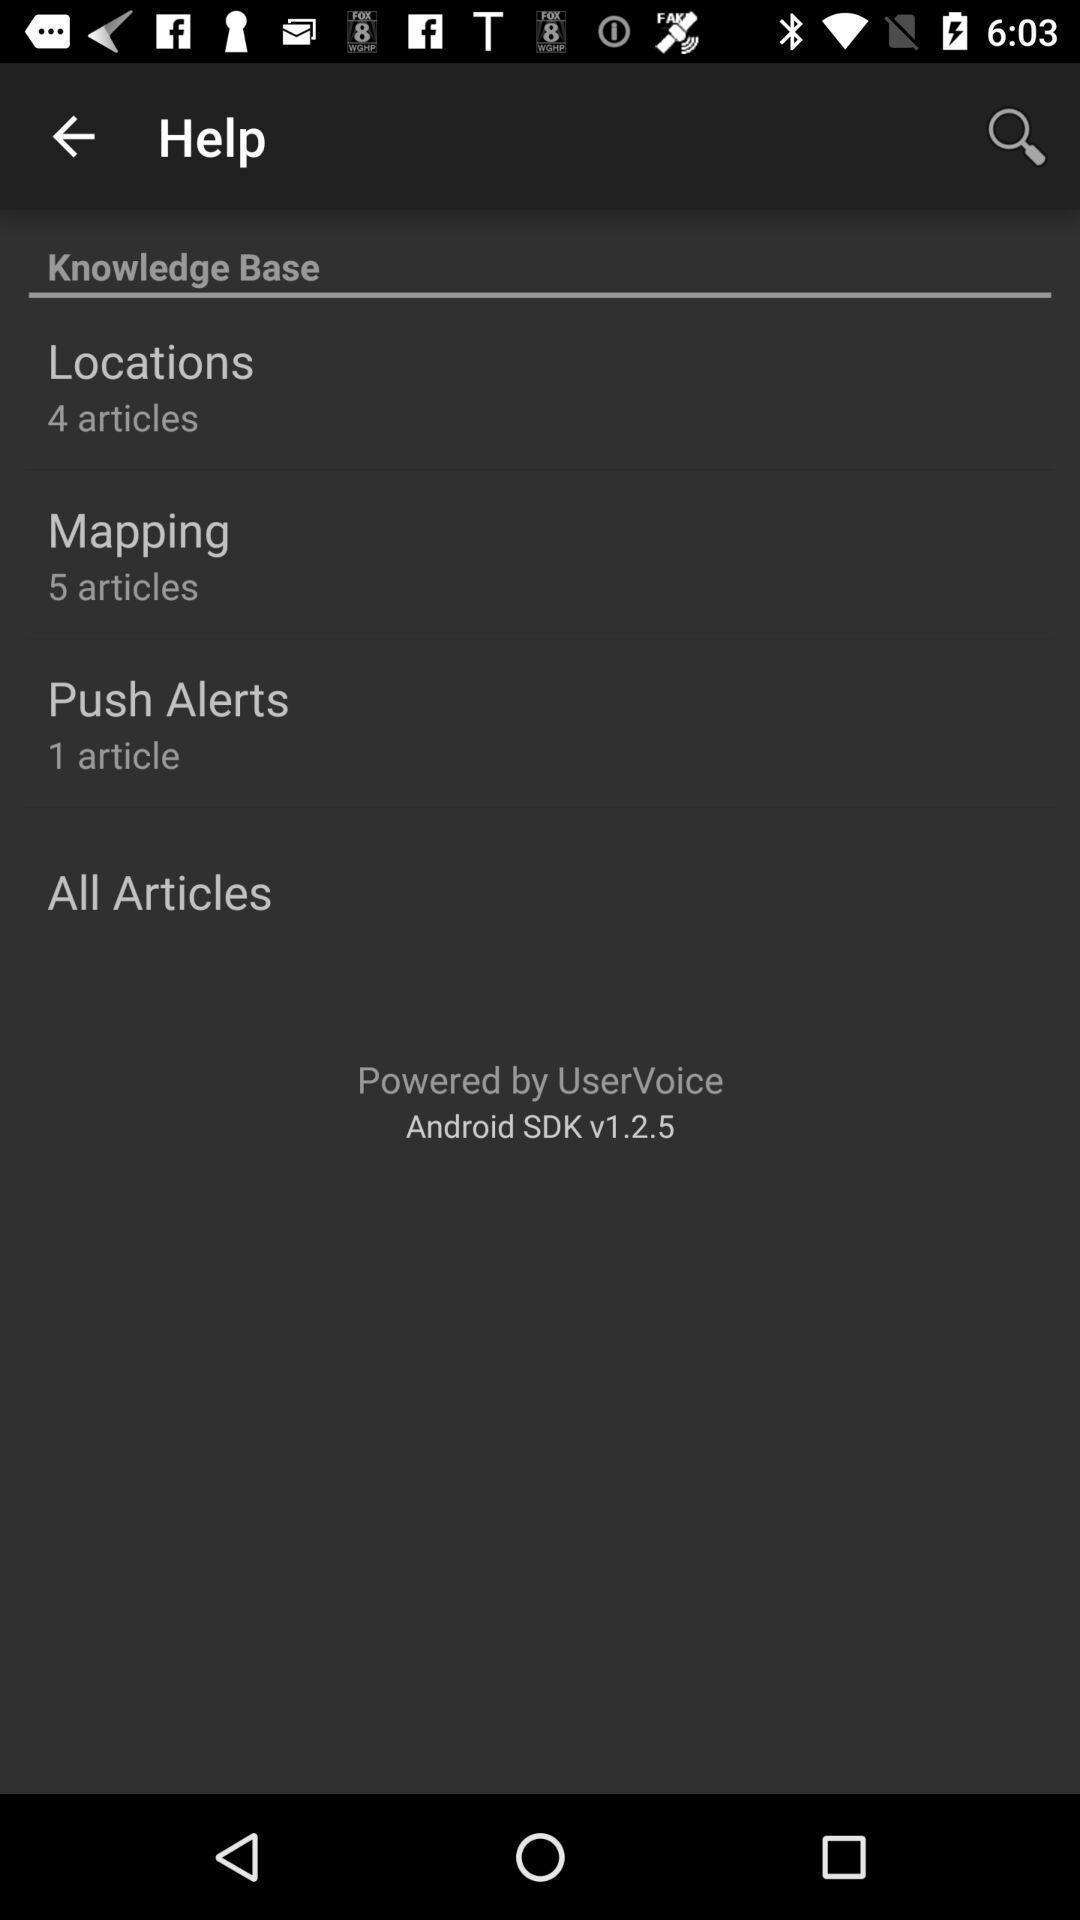What is the overall content of this screenshot? Screen shows different options. 